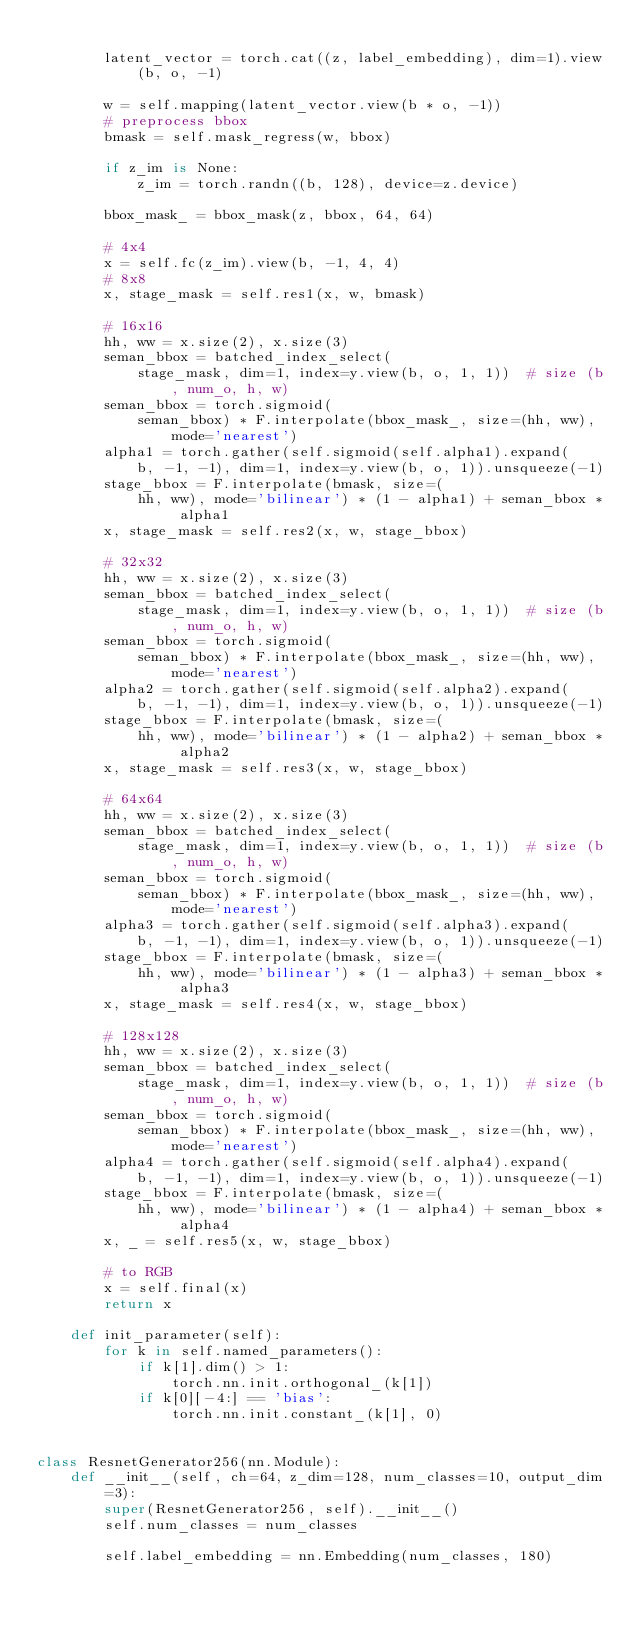Convert code to text. <code><loc_0><loc_0><loc_500><loc_500><_Python_>
        latent_vector = torch.cat((z, label_embedding), dim=1).view(b, o, -1)

        w = self.mapping(latent_vector.view(b * o, -1))
        # preprocess bbox
        bmask = self.mask_regress(w, bbox)

        if z_im is None:
            z_im = torch.randn((b, 128), device=z.device)

        bbox_mask_ = bbox_mask(z, bbox, 64, 64)

        # 4x4
        x = self.fc(z_im).view(b, -1, 4, 4)
        # 8x8
        x, stage_mask = self.res1(x, w, bmask)

        # 16x16
        hh, ww = x.size(2), x.size(3)
        seman_bbox = batched_index_select(
            stage_mask, dim=1, index=y.view(b, o, 1, 1))  # size (b, num_o, h, w)
        seman_bbox = torch.sigmoid(
            seman_bbox) * F.interpolate(bbox_mask_, size=(hh, ww), mode='nearest')
        alpha1 = torch.gather(self.sigmoid(self.alpha1).expand(
            b, -1, -1), dim=1, index=y.view(b, o, 1)).unsqueeze(-1)
        stage_bbox = F.interpolate(bmask, size=(
            hh, ww), mode='bilinear') * (1 - alpha1) + seman_bbox * alpha1
        x, stage_mask = self.res2(x, w, stage_bbox)

        # 32x32
        hh, ww = x.size(2), x.size(3)
        seman_bbox = batched_index_select(
            stage_mask, dim=1, index=y.view(b, o, 1, 1))  # size (b, num_o, h, w)
        seman_bbox = torch.sigmoid(
            seman_bbox) * F.interpolate(bbox_mask_, size=(hh, ww), mode='nearest')
        alpha2 = torch.gather(self.sigmoid(self.alpha2).expand(
            b, -1, -1), dim=1, index=y.view(b, o, 1)).unsqueeze(-1)
        stage_bbox = F.interpolate(bmask, size=(
            hh, ww), mode='bilinear') * (1 - alpha2) + seman_bbox * alpha2
        x, stage_mask = self.res3(x, w, stage_bbox)

        # 64x64
        hh, ww = x.size(2), x.size(3)
        seman_bbox = batched_index_select(
            stage_mask, dim=1, index=y.view(b, o, 1, 1))  # size (b, num_o, h, w)
        seman_bbox = torch.sigmoid(
            seman_bbox) * F.interpolate(bbox_mask_, size=(hh, ww), mode='nearest')
        alpha3 = torch.gather(self.sigmoid(self.alpha3).expand(
            b, -1, -1), dim=1, index=y.view(b, o, 1)).unsqueeze(-1)
        stage_bbox = F.interpolate(bmask, size=(
            hh, ww), mode='bilinear') * (1 - alpha3) + seman_bbox * alpha3
        x, stage_mask = self.res4(x, w, stage_bbox)

        # 128x128
        hh, ww = x.size(2), x.size(3)
        seman_bbox = batched_index_select(
            stage_mask, dim=1, index=y.view(b, o, 1, 1))  # size (b, num_o, h, w)
        seman_bbox = torch.sigmoid(
            seman_bbox) * F.interpolate(bbox_mask_, size=(hh, ww), mode='nearest')
        alpha4 = torch.gather(self.sigmoid(self.alpha4).expand(
            b, -1, -1), dim=1, index=y.view(b, o, 1)).unsqueeze(-1)
        stage_bbox = F.interpolate(bmask, size=(
            hh, ww), mode='bilinear') * (1 - alpha4) + seman_bbox * alpha4
        x, _ = self.res5(x, w, stage_bbox)

        # to RGB
        x = self.final(x)
        return x

    def init_parameter(self):
        for k in self.named_parameters():
            if k[1].dim() > 1:
                torch.nn.init.orthogonal_(k[1])
            if k[0][-4:] == 'bias':
                torch.nn.init.constant_(k[1], 0)


class ResnetGenerator256(nn.Module):
    def __init__(self, ch=64, z_dim=128, num_classes=10, output_dim=3):
        super(ResnetGenerator256, self).__init__()
        self.num_classes = num_classes

        self.label_embedding = nn.Embedding(num_classes, 180)
</code> 